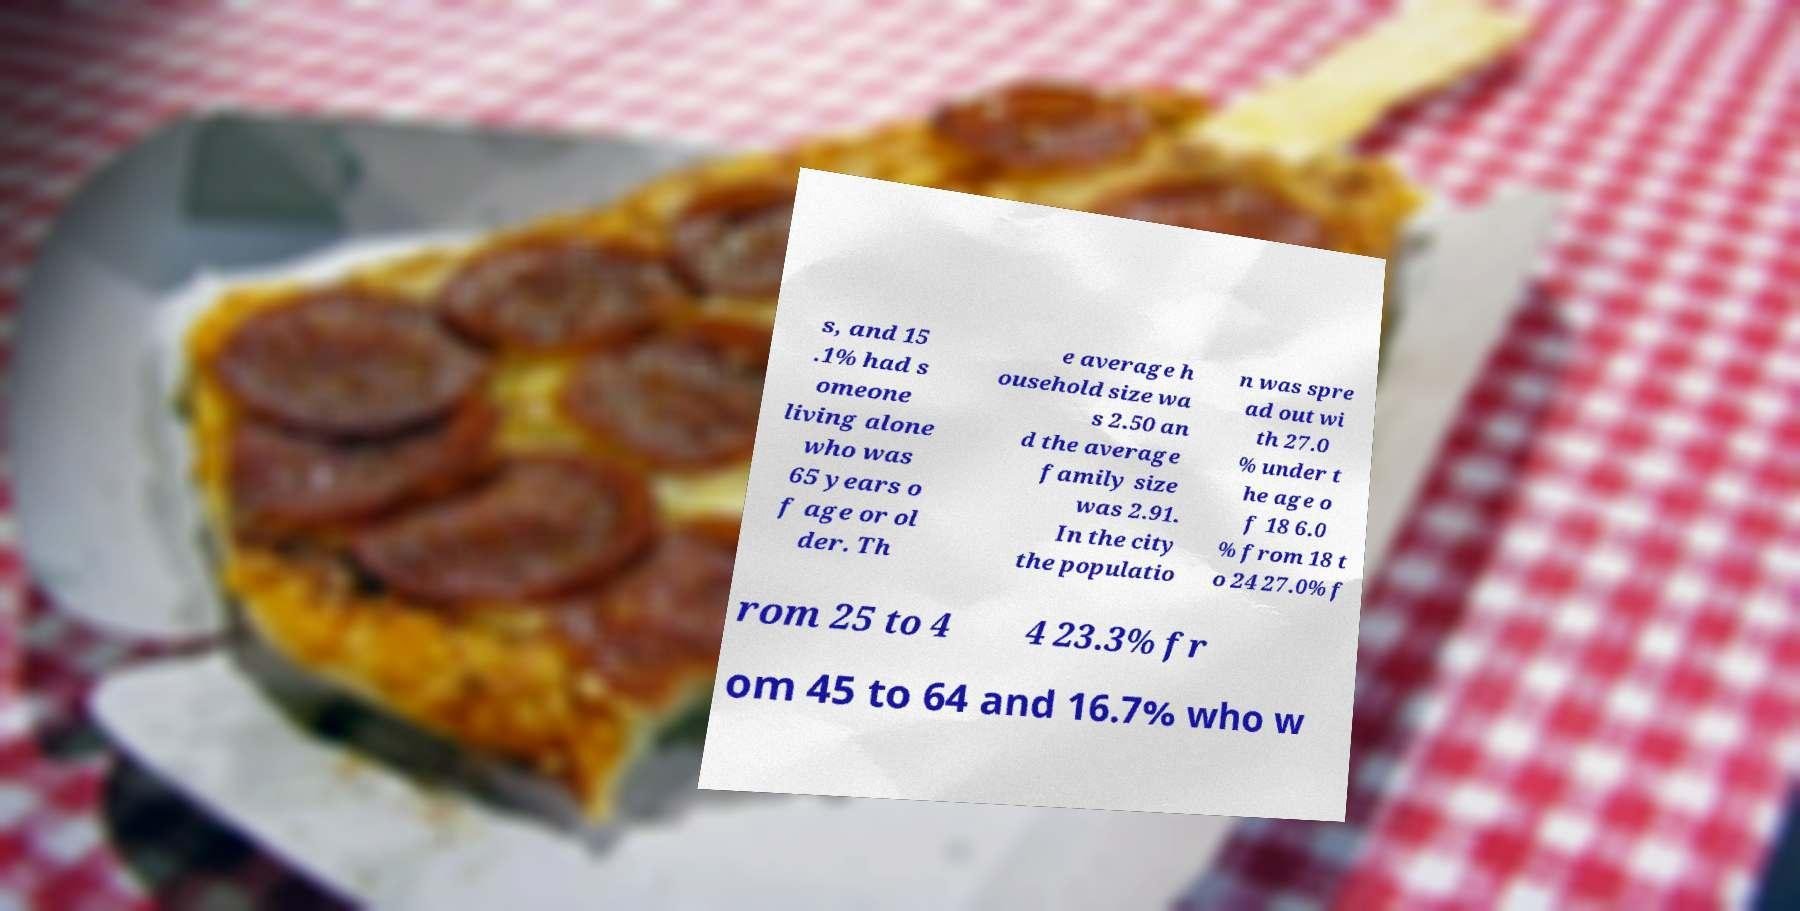I need the written content from this picture converted into text. Can you do that? s, and 15 .1% had s omeone living alone who was 65 years o f age or ol der. Th e average h ousehold size wa s 2.50 an d the average family size was 2.91. In the city the populatio n was spre ad out wi th 27.0 % under t he age o f 18 6.0 % from 18 t o 24 27.0% f rom 25 to 4 4 23.3% fr om 45 to 64 and 16.7% who w 